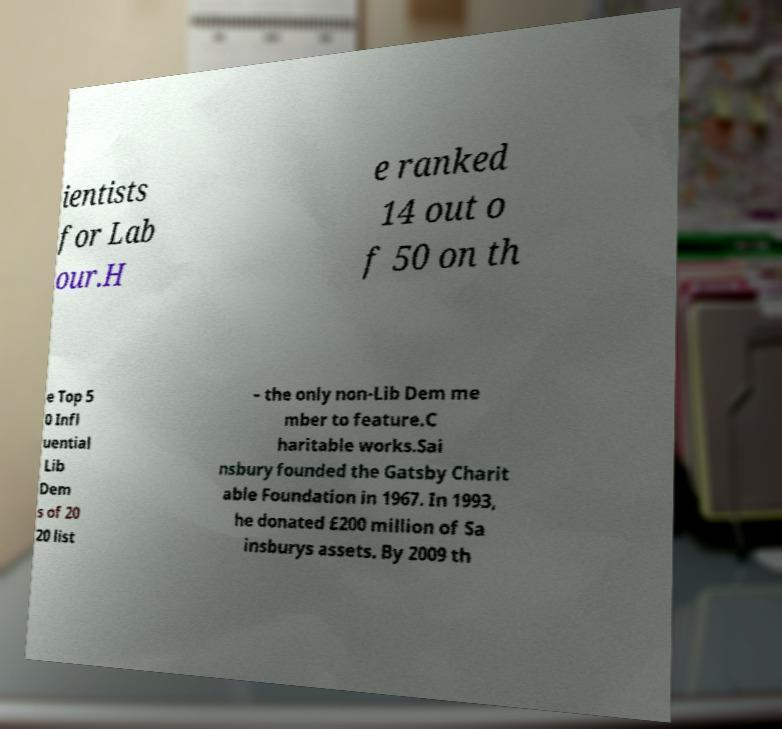Could you extract and type out the text from this image? ientists for Lab our.H e ranked 14 out o f 50 on th e Top 5 0 Infl uential Lib Dem s of 20 20 list – the only non-Lib Dem me mber to feature.C haritable works.Sai nsbury founded the Gatsby Charit able Foundation in 1967. In 1993, he donated £200 million of Sa insburys assets. By 2009 th 